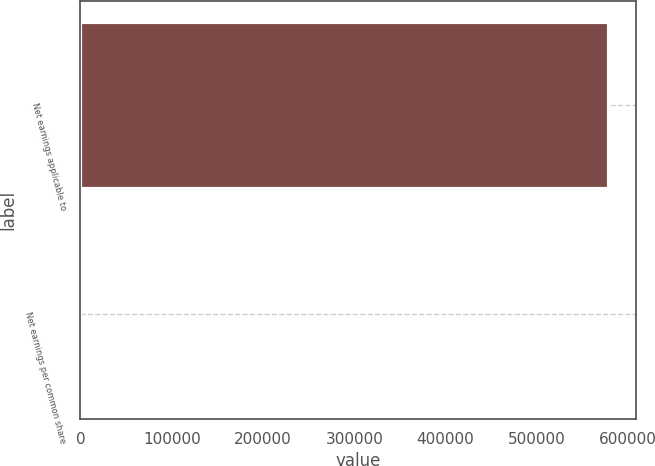<chart> <loc_0><loc_0><loc_500><loc_500><bar_chart><fcel>Net earnings applicable to<fcel>Net earnings per common share<nl><fcel>579290<fcel>5.46<nl></chart> 